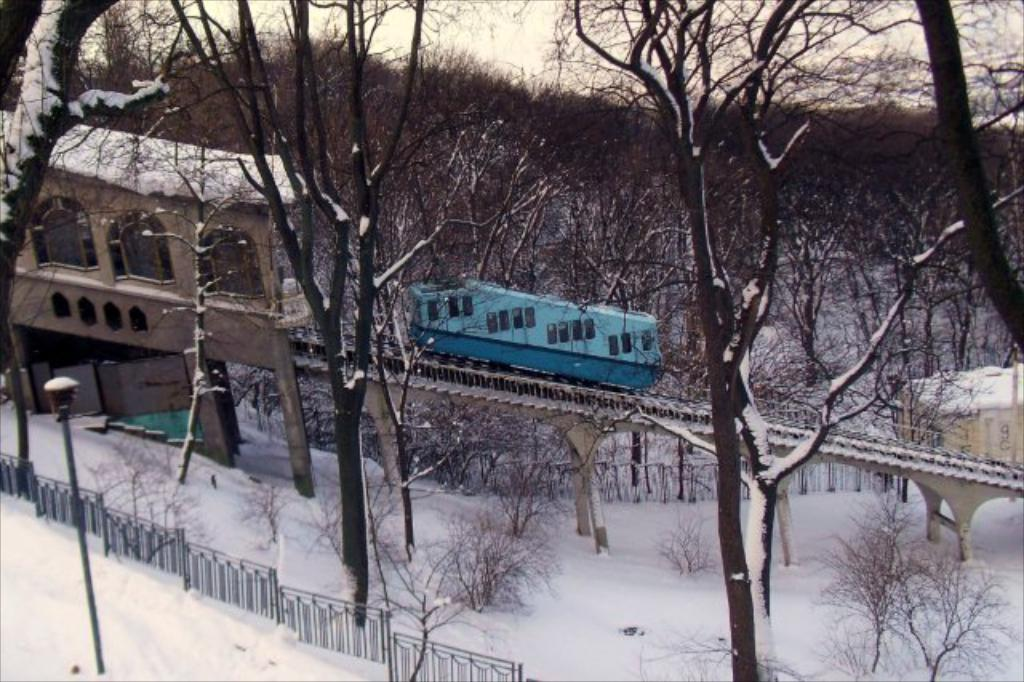What is the main subject of the image? The main subject of the image is a train. What other structures or objects can be seen in the image? There is a house, a fence, a street light, and trees in the background of the image. What is the weather like in the image? The presence of snow in the image suggests that it is a snowy or winter scene. What is visible in the background of the image? The sky is visible in the background of the image. What type of reaction can be seen from the swing in the image? There is no swing present in the image; it features a train, a house, a fence, a street light, trees, snow, and the sky. How many items can be found in the pocket of the person in the image? There is no person present in the image, so it is not possible to determine what might be in their pocket. 